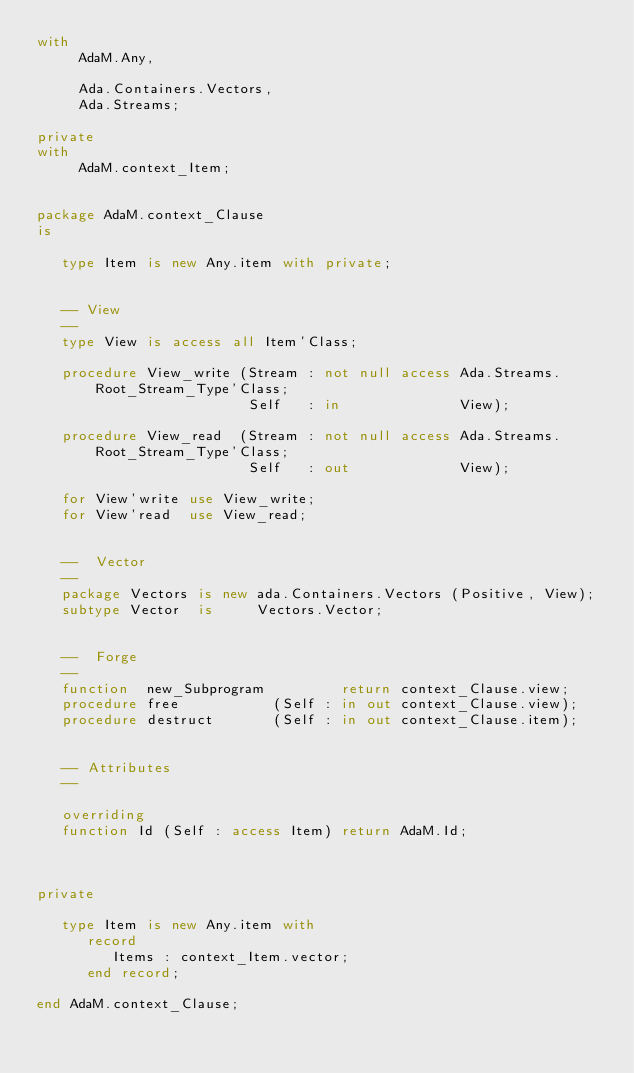<code> <loc_0><loc_0><loc_500><loc_500><_Ada_>with
     AdaM.Any,

     Ada.Containers.Vectors,
     Ada.Streams;

private
with
     AdaM.context_Item;


package AdaM.context_Clause
is

   type Item is new Any.item with private;


   -- View
   --
   type View is access all Item'Class;

   procedure View_write (Stream : not null access Ada.Streams.Root_Stream_Type'Class;
                         Self   : in              View);

   procedure View_read  (Stream : not null access Ada.Streams.Root_Stream_Type'Class;
                         Self   : out             View);

   for View'write use View_write;
   for View'read  use View_read;


   --  Vector
   --
   package Vectors is new ada.Containers.Vectors (Positive, View);
   subtype Vector  is     Vectors.Vector;


   --  Forge
   --
   function  new_Subprogram         return context_Clause.view;
   procedure free           (Self : in out context_Clause.view);
   procedure destruct       (Self : in out context_Clause.item);


   -- Attributes
   --

   overriding
   function Id (Self : access Item) return AdaM.Id;



private

   type Item is new Any.item with
      record
         Items : context_Item.vector;
      end record;

end AdaM.context_Clause;
</code> 